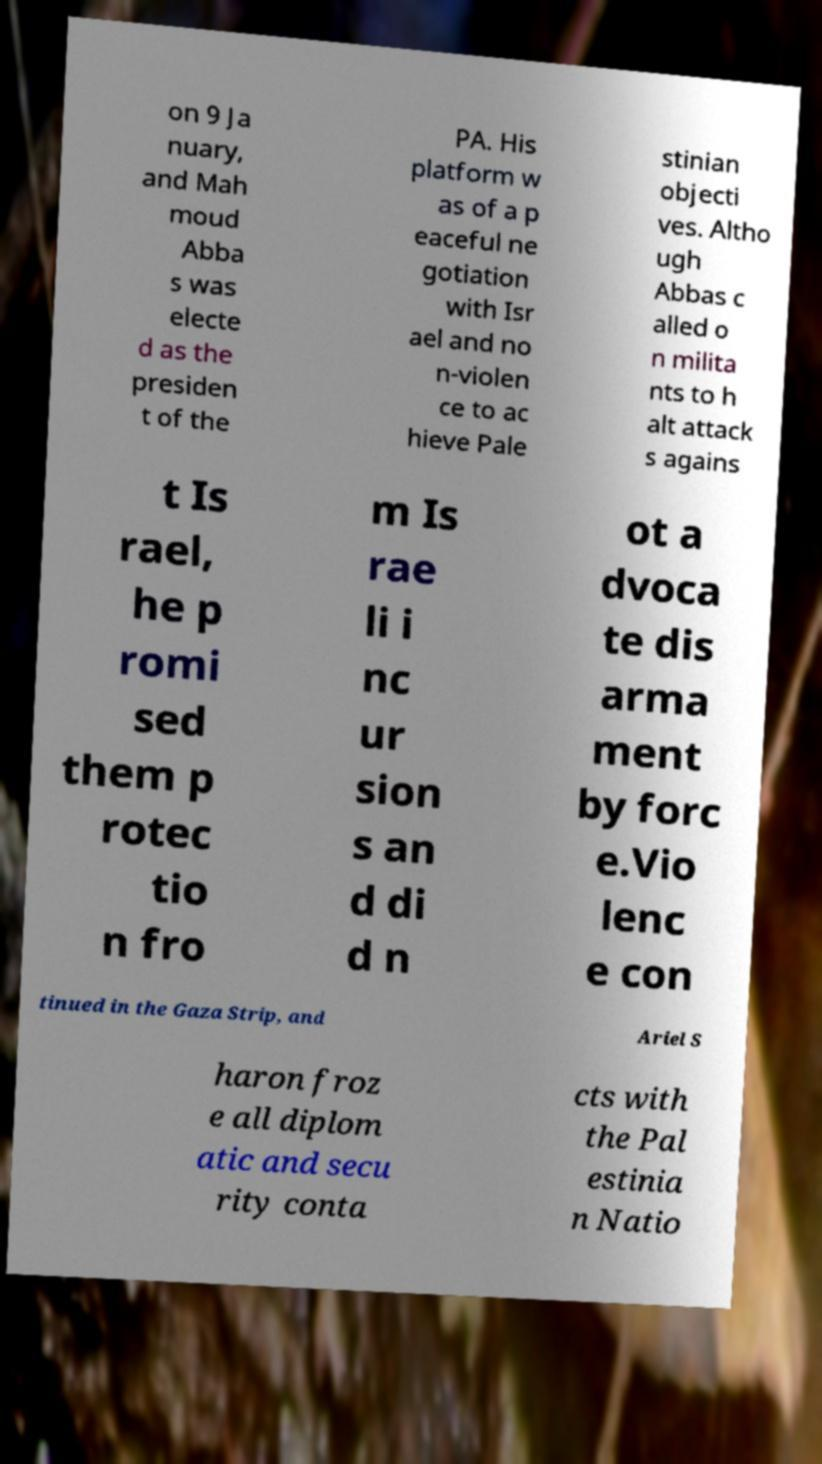Can you accurately transcribe the text from the provided image for me? on 9 Ja nuary, and Mah moud Abba s was electe d as the presiden t of the PA. His platform w as of a p eaceful ne gotiation with Isr ael and no n-violen ce to ac hieve Pale stinian objecti ves. Altho ugh Abbas c alled o n milita nts to h alt attack s agains t Is rael, he p romi sed them p rotec tio n fro m Is rae li i nc ur sion s an d di d n ot a dvoca te dis arma ment by forc e.Vio lenc e con tinued in the Gaza Strip, and Ariel S haron froz e all diplom atic and secu rity conta cts with the Pal estinia n Natio 